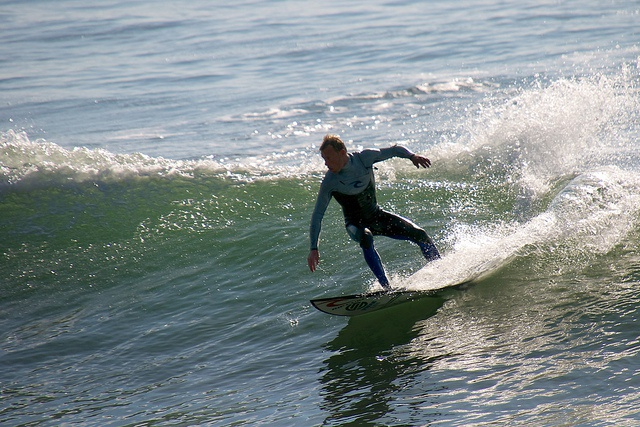Describe the objects in this image and their specific colors. I can see people in gray, black, darkblue, and purple tones and surfboard in gray, black, and darkgreen tones in this image. 